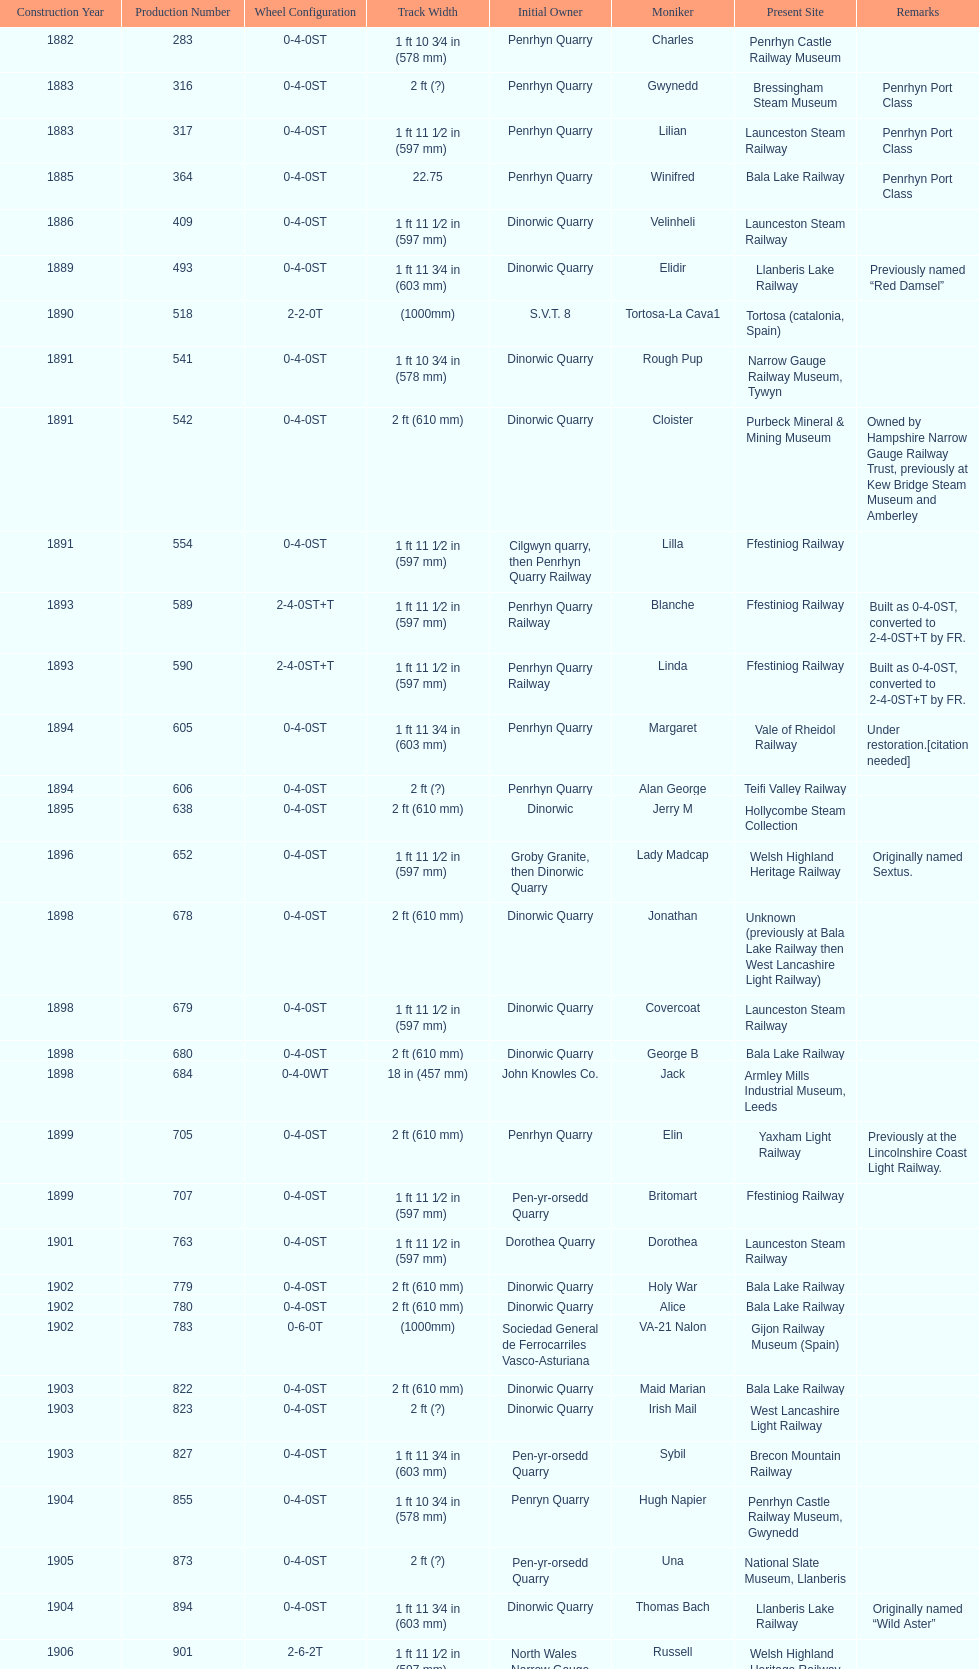After 1940, how many steam locomotives were built? 2. 